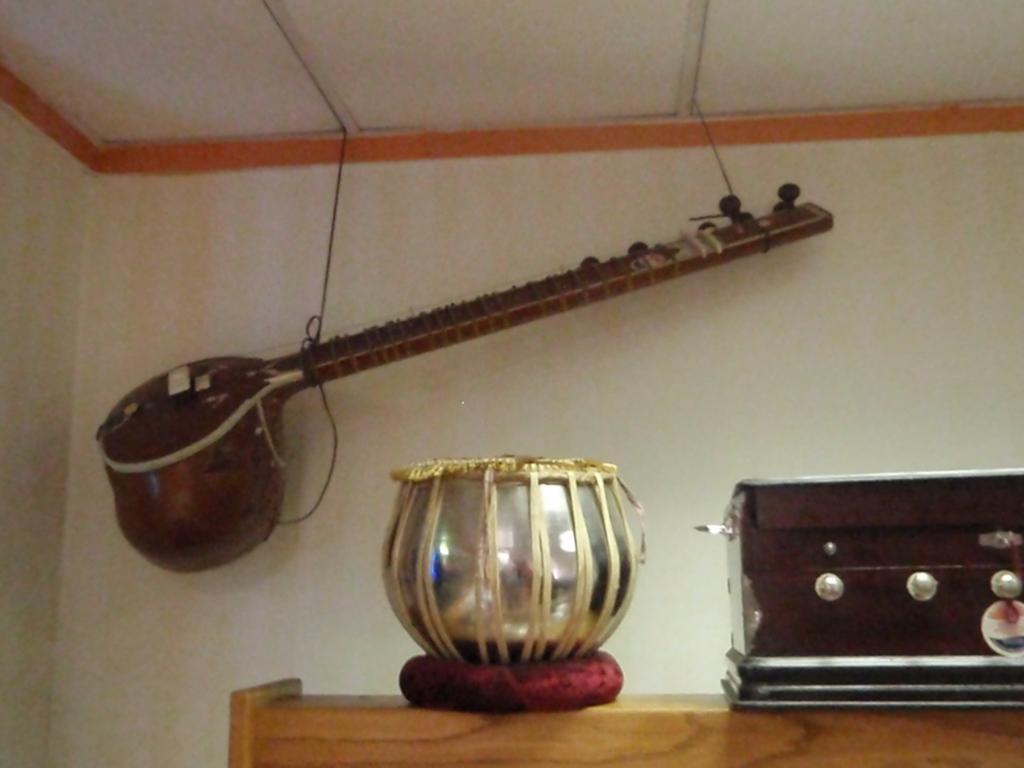What type of furniture is in the image? There is a table in the image. What musical instrument is on the left side of the table? A tabla is present on the left side of the table. What musical instrument is on the right side of the table? A harmony is on the right side of the table. What musical instrument can be seen in the background of the image? There is a sitar in the background of the image. How is the sitar positioned in the image? The sitar is hanged on the wall. What type of fowl can be seen in the image? There is no fowl present in the image; it features a table with musical instruments. How many pails are visible in the image? There are no pails present in the image. 